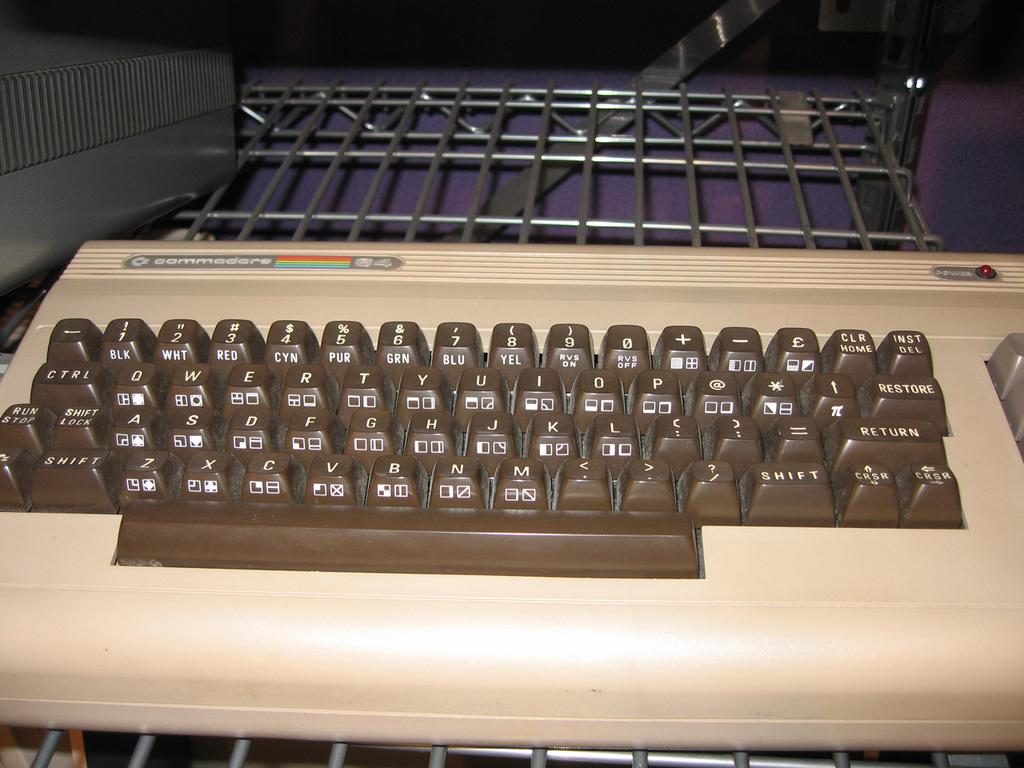<image>
Give a short and clear explanation of the subsequent image. A beige and brown commodore branded keyboard sitting on a shelf. 